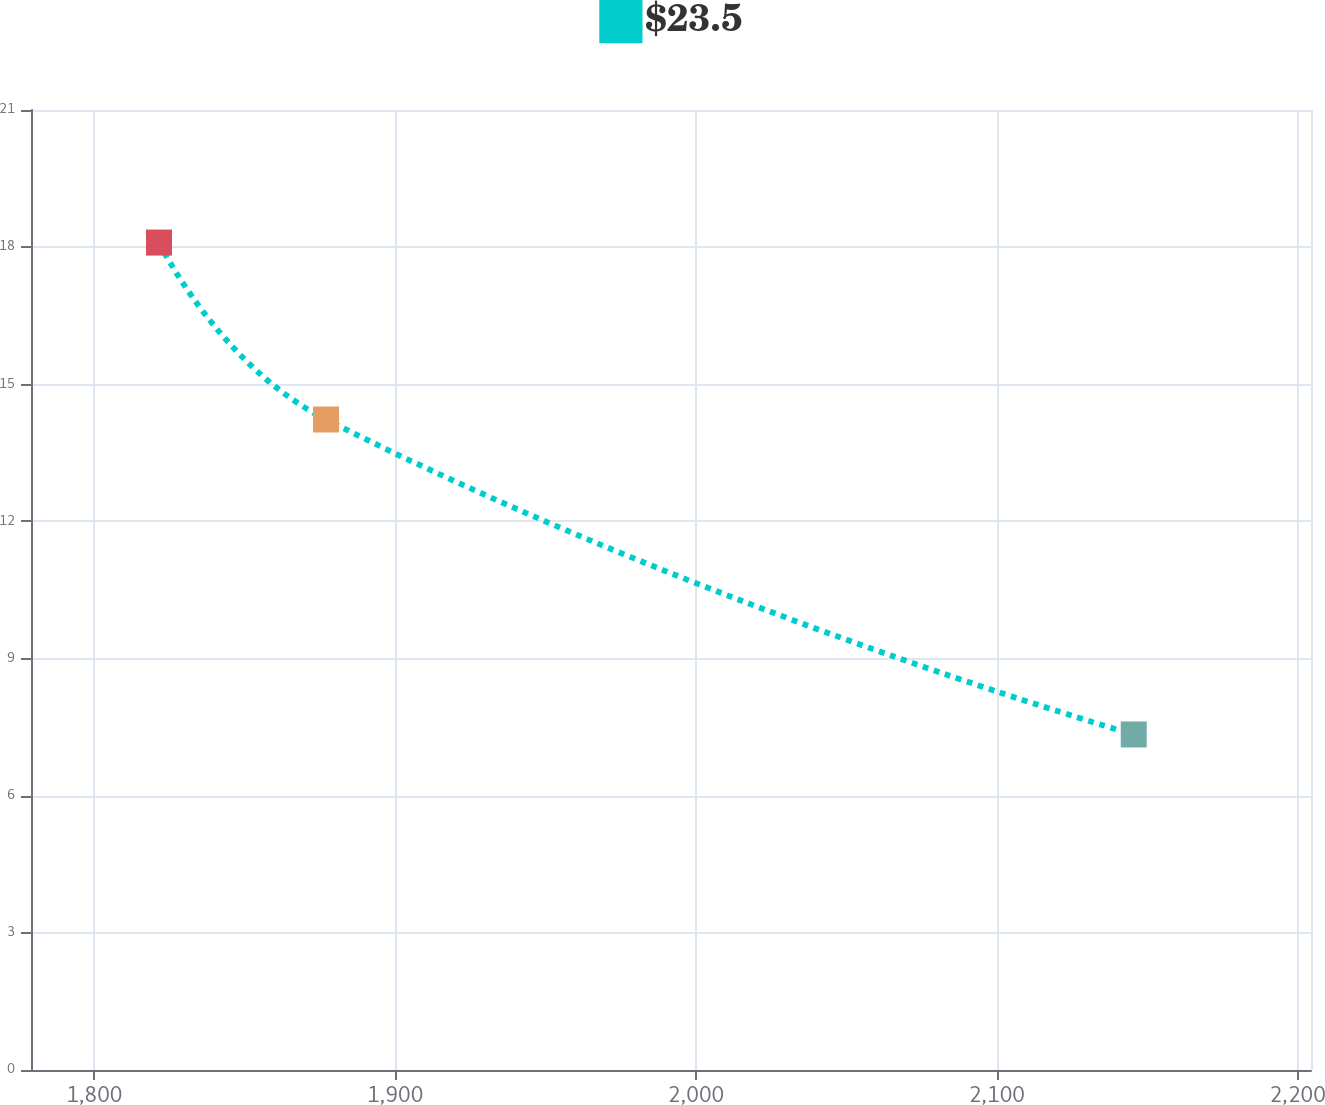Convert chart. <chart><loc_0><loc_0><loc_500><loc_500><line_chart><ecel><fcel>$23.5<nl><fcel>1821.5<fcel>18.1<nl><fcel>1877.02<fcel>14.23<nl><fcel>2145.52<fcel>7.34<nl><fcel>2246.99<fcel>6.03<nl></chart> 